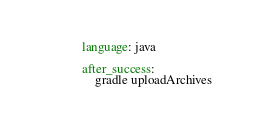<code> <loc_0><loc_0><loc_500><loc_500><_YAML_>language: java

after_success:
    gradle uploadArchives
</code> 